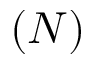<formula> <loc_0><loc_0><loc_500><loc_500>{ ( N ) }</formula> 